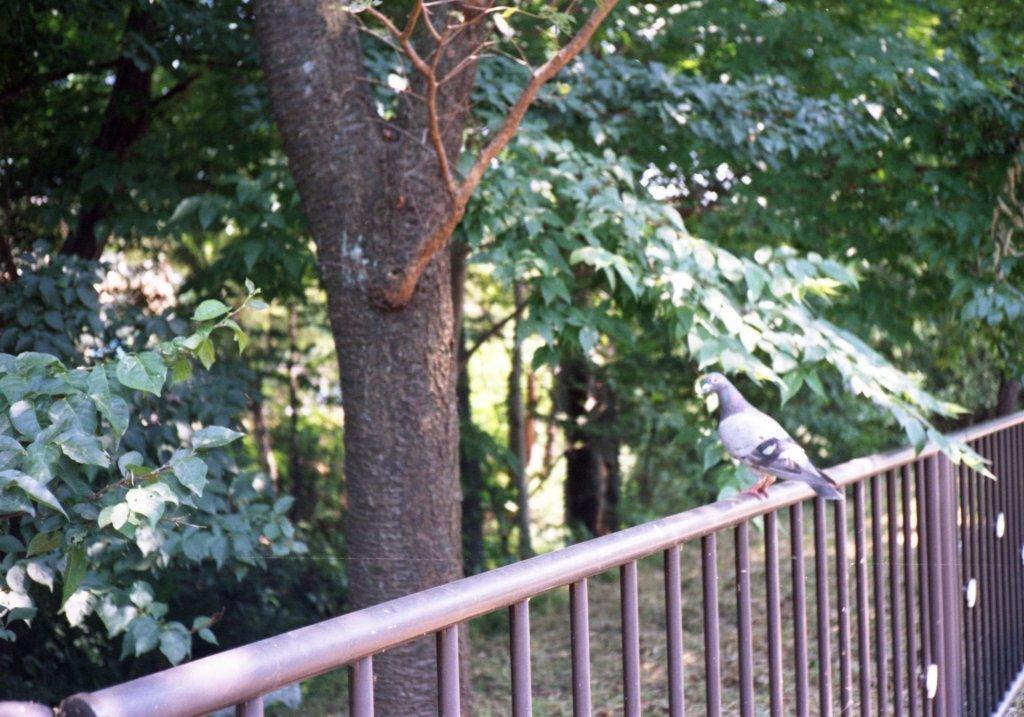What animal can be seen in the image? There is a bird standing on a railing in the image. What type of natural environment is visible in the image? There are trees visible in the image. What type of question is the bird asking in the image? There is no indication in the image that the bird is asking any question. 